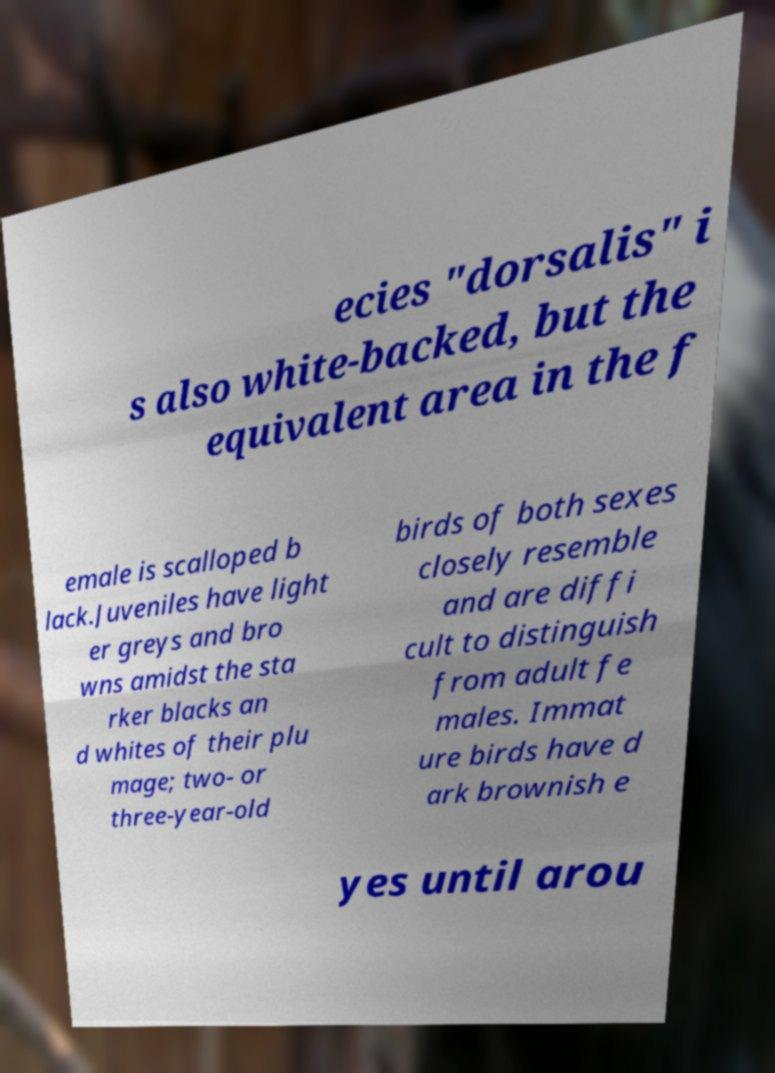Can you accurately transcribe the text from the provided image for me? ecies "dorsalis" i s also white-backed, but the equivalent area in the f emale is scalloped b lack.Juveniles have light er greys and bro wns amidst the sta rker blacks an d whites of their plu mage; two- or three-year-old birds of both sexes closely resemble and are diffi cult to distinguish from adult fe males. Immat ure birds have d ark brownish e yes until arou 